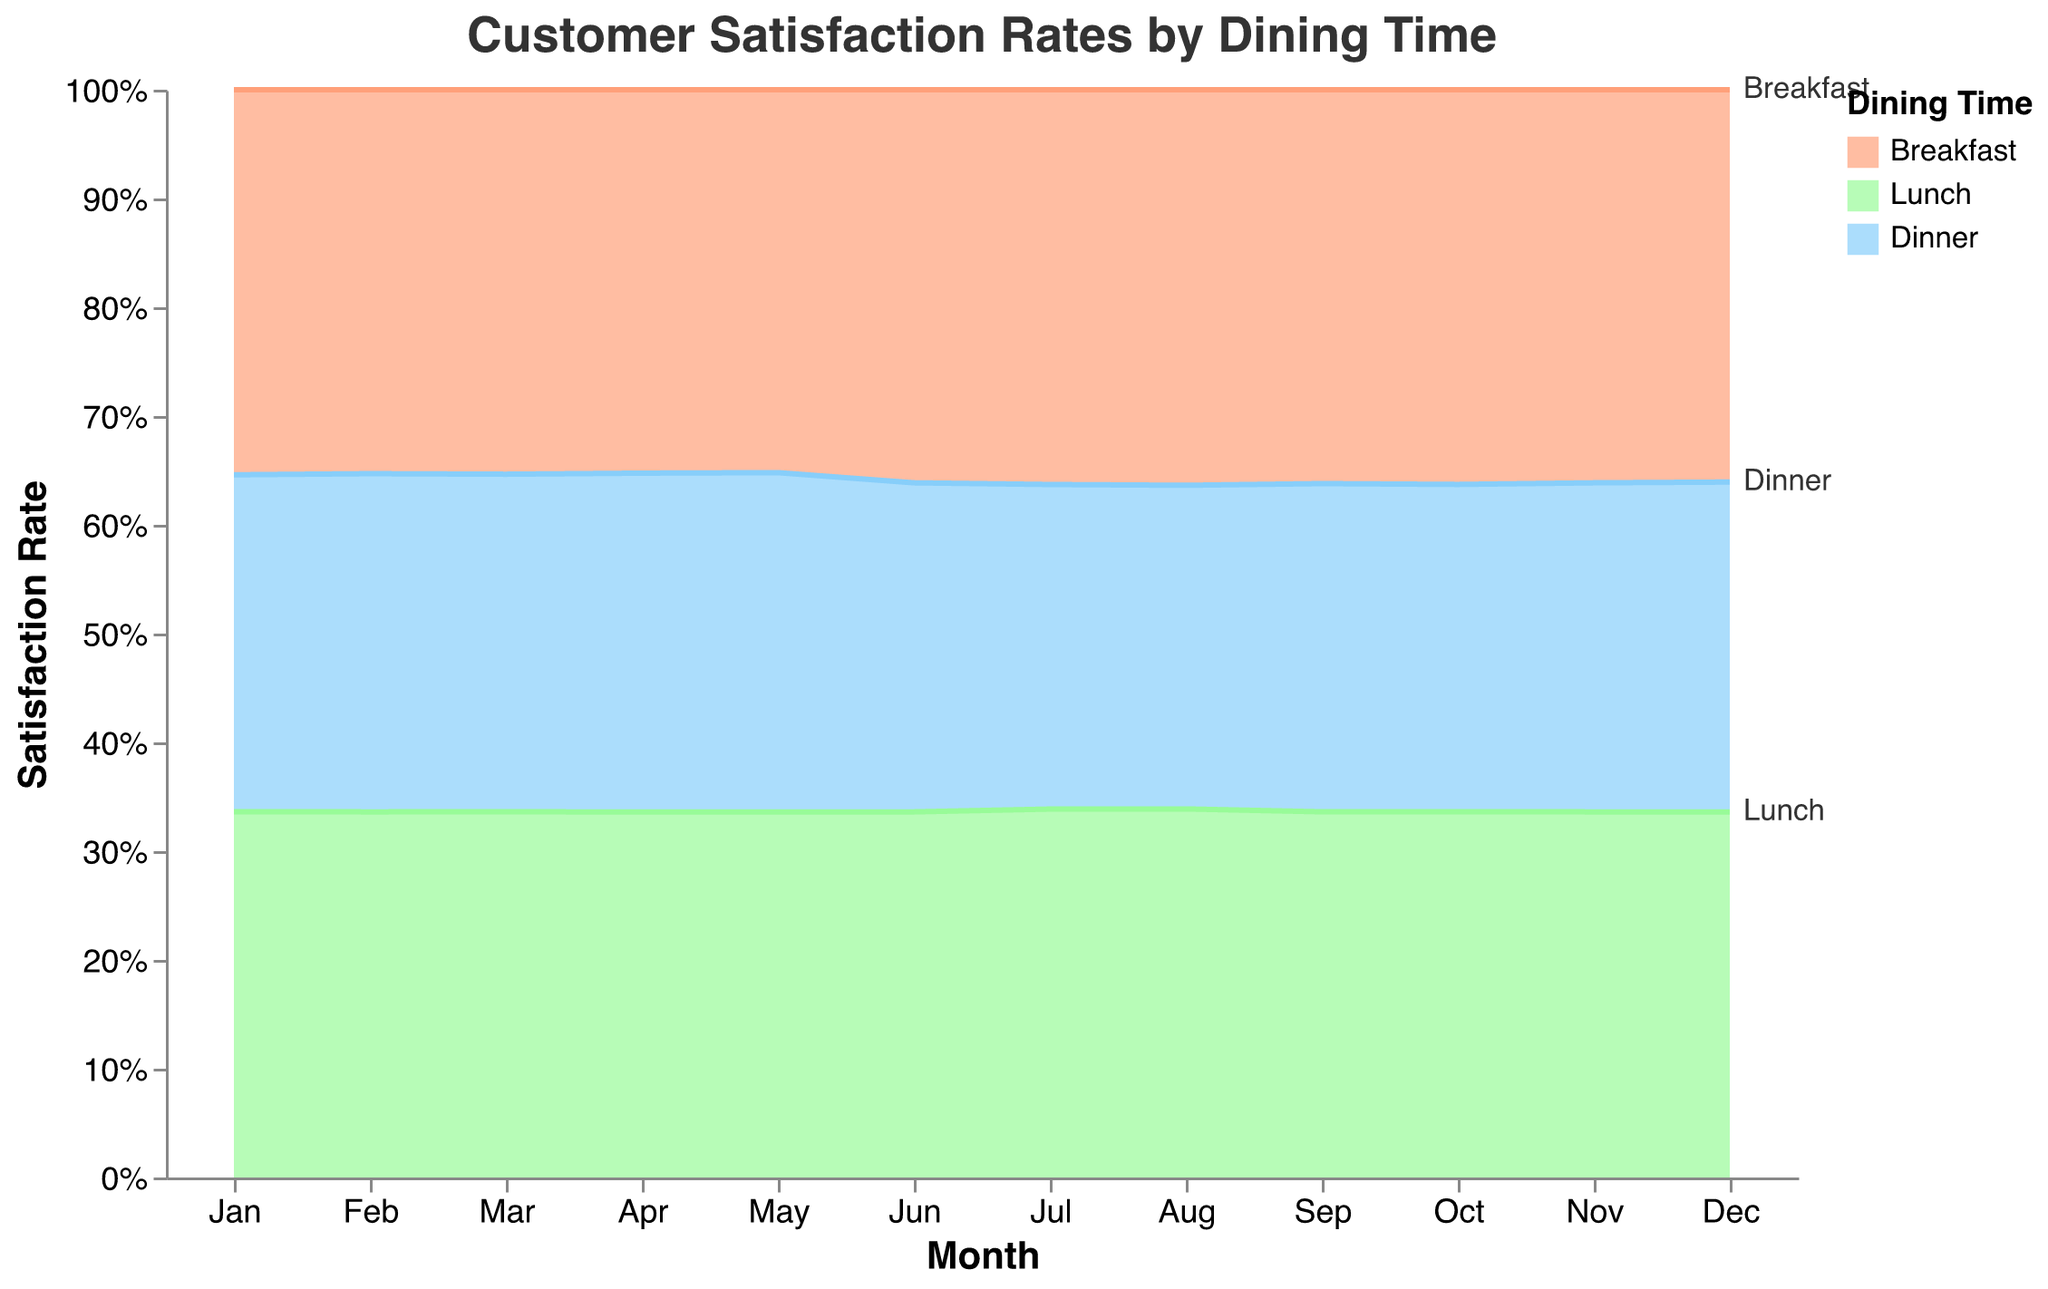What is the overall title of the chart? The title is located at the top center of the chart and reads "Customer Satisfaction Rates by Dining Time".
Answer: Customer Satisfaction Rates by Dining Time Which dining time has the highest proportion of "Very Satisfied" customers in July? In July, the "Very Satisfied" section for each dining time can be compared. The Breakfast dining time has the highest section for "Very Satisfied".
Answer: Breakfast Which month shows the highest dissatisfaction (sum of "Dissatisfied" and "Very Dissatisfied") for Dinner? Dissatisfaction rates must be observed for each month. October has the highest sum of "Dissatisfied" and "Very Dissatisfied" rates for Dinner.
Answer: October What trend do you observe for the "Very Dissatisfied" rate in Dinner from Jan to Dec? By looking at the bottom section of the Dinner area for each month, the "Very Dissatisfied" rate shows some fluctuation but generally remains between 3-6%.
Answer: Fluctuating between 3-6% How does Lunch's "Very Satisfied" percentage in December compare to its "Very Satisfied" percentage in June? In December, the "Very Satisfied" percentage for Lunch is slightly higher than in June, where Lunch's "Very Satisfied" section appears larger.
Answer: Higher in December Does any dining time show a sudden drop in satisfaction ("Very Satisfied" or "Satisfied") within the year? Reviewing the areas for "Very Satisfied" and "Satisfied," Dinner shows a sudden drop in October with a noticeable decrease in both categories.
Answer: Dinner in October What is the average "Very Satisfied" rate for Lunch over the year? Summing the "Very Satisfied" percentages for Lunch over each month and dividing by 12. The values add up to 484, so 484/12 = 40.33%.
Answer: 40.33% Is there any month where Breakfast's "Very Satisfied" rate is less than 40%? Reviewing each month's Breakfast section, none of them have "Very Satisfied" rates below 40%.
Answer: No Which dining time appears to have the most consistent customer satisfaction rates throughout the year? Observing all the segments through the months, Lunch seems to have the most consistent distribution without major fluctuations.
Answer: Lunch What is the proportion of "Neutral" customers for Dinner in April? For April, the "Neutral" proportion in Dinner can be assessed. It appears to be a noticeable but smaller section compared to the other satisfaction levels.
Answer: 23% 